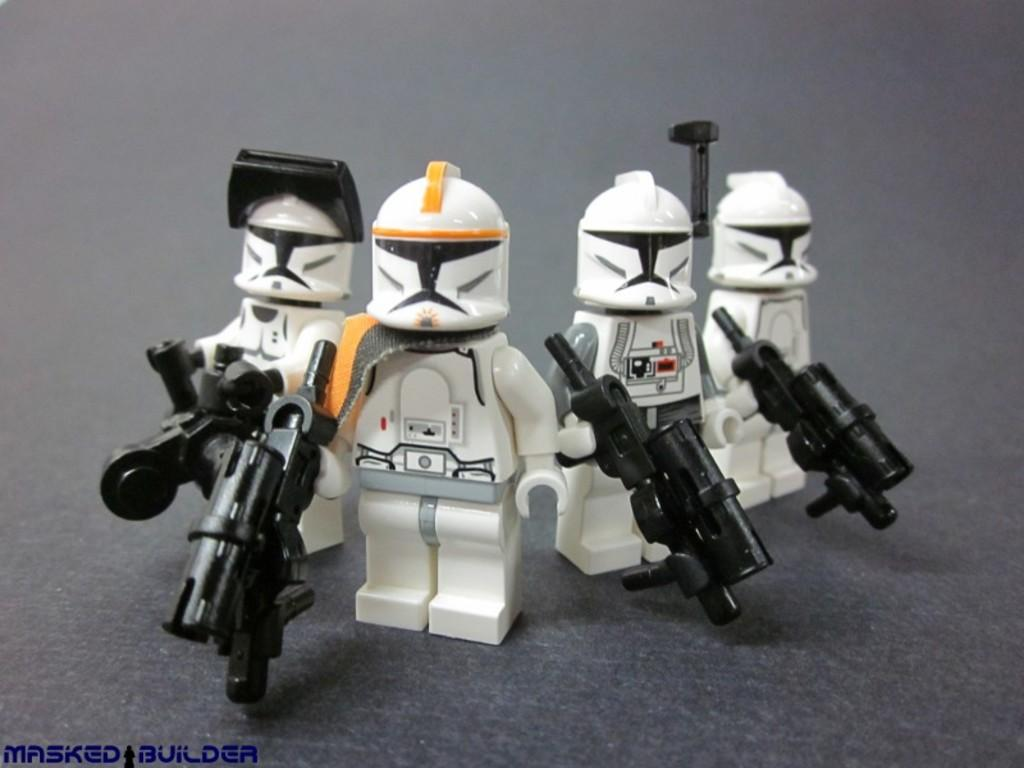What type of objects are in the image? There is a group of toys in the image. What color are the toys? The toys are white in color. What color is the surface on which the toys are placed? The toys are on a black color surface. Where can text be found in the image? There is text written on the bottom left of the image. How many wings can be seen on the house in the image? There is no house present in the image, and therefore no wings can be seen. What type of note is attached to the toys in the image? There is no note attached to the toys in the image. 